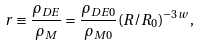<formula> <loc_0><loc_0><loc_500><loc_500>r \equiv \frac { \rho _ { D E } } { \rho _ { M } } = \frac { \rho _ { D E 0 } } { \rho _ { M 0 } } ( R / R _ { 0 } ) ^ { - 3 w } ,</formula> 